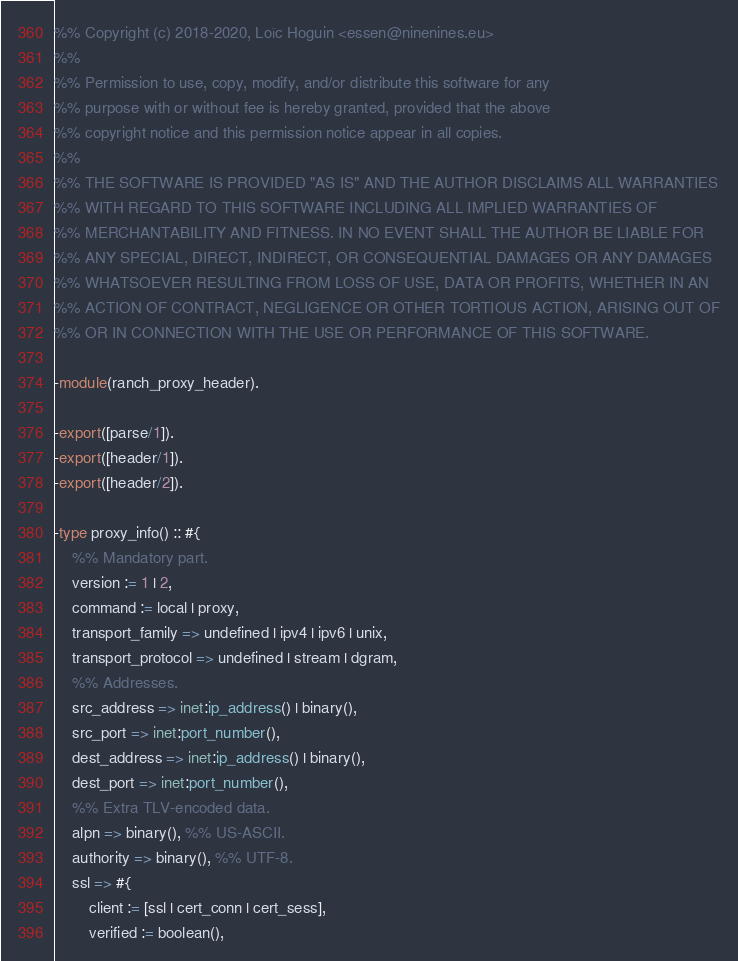<code> <loc_0><loc_0><loc_500><loc_500><_Erlang_>%% Copyright (c) 2018-2020, Loïc Hoguin <essen@ninenines.eu>
%%
%% Permission to use, copy, modify, and/or distribute this software for any
%% purpose with or without fee is hereby granted, provided that the above
%% copyright notice and this permission notice appear in all copies.
%%
%% THE SOFTWARE IS PROVIDED "AS IS" AND THE AUTHOR DISCLAIMS ALL WARRANTIES
%% WITH REGARD TO THIS SOFTWARE INCLUDING ALL IMPLIED WARRANTIES OF
%% MERCHANTABILITY AND FITNESS. IN NO EVENT SHALL THE AUTHOR BE LIABLE FOR
%% ANY SPECIAL, DIRECT, INDIRECT, OR CONSEQUENTIAL DAMAGES OR ANY DAMAGES
%% WHATSOEVER RESULTING FROM LOSS OF USE, DATA OR PROFITS, WHETHER IN AN
%% ACTION OF CONTRACT, NEGLIGENCE OR OTHER TORTIOUS ACTION, ARISING OUT OF
%% OR IN CONNECTION WITH THE USE OR PERFORMANCE OF THIS SOFTWARE.

-module(ranch_proxy_header).

-export([parse/1]).
-export([header/1]).
-export([header/2]).

-type proxy_info() :: #{
	%% Mandatory part.
	version := 1 | 2,
	command := local | proxy,
	transport_family => undefined | ipv4 | ipv6 | unix,
	transport_protocol => undefined | stream | dgram,
	%% Addresses.
	src_address => inet:ip_address() | binary(),
	src_port => inet:port_number(),
	dest_address => inet:ip_address() | binary(),
	dest_port => inet:port_number(),
	%% Extra TLV-encoded data.
	alpn => binary(), %% US-ASCII.
	authority => binary(), %% UTF-8.
	ssl => #{
		client := [ssl | cert_conn | cert_sess],
		verified := boolean(),</code> 